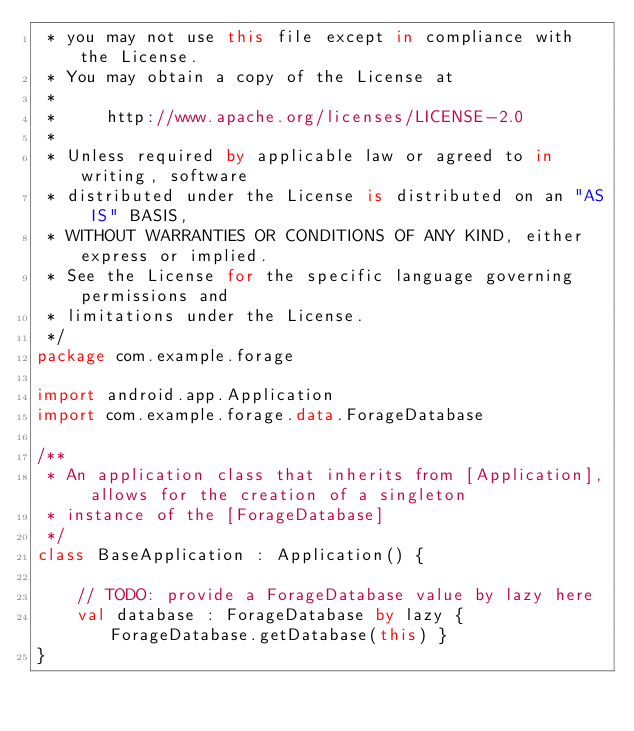<code> <loc_0><loc_0><loc_500><loc_500><_Kotlin_> * you may not use this file except in compliance with the License.
 * You may obtain a copy of the License at
 *
 *     http://www.apache.org/licenses/LICENSE-2.0
 *
 * Unless required by applicable law or agreed to in writing, software
 * distributed under the License is distributed on an "AS IS" BASIS,
 * WITHOUT WARRANTIES OR CONDITIONS OF ANY KIND, either express or implied.
 * See the License for the specific language governing permissions and
 * limitations under the License.
 */
package com.example.forage

import android.app.Application
import com.example.forage.data.ForageDatabase

/**
 * An application class that inherits from [Application], allows for the creation of a singleton
 * instance of the [ForageDatabase]
 */
class BaseApplication : Application() {

    // TODO: provide a ForageDatabase value by lazy here
    val database : ForageDatabase by lazy { ForageDatabase.getDatabase(this) }
}</code> 